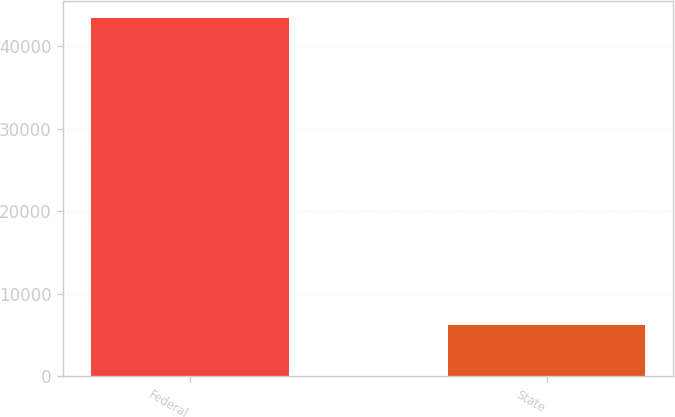<chart> <loc_0><loc_0><loc_500><loc_500><bar_chart><fcel>Federal<fcel>State<nl><fcel>43334<fcel>6180<nl></chart> 